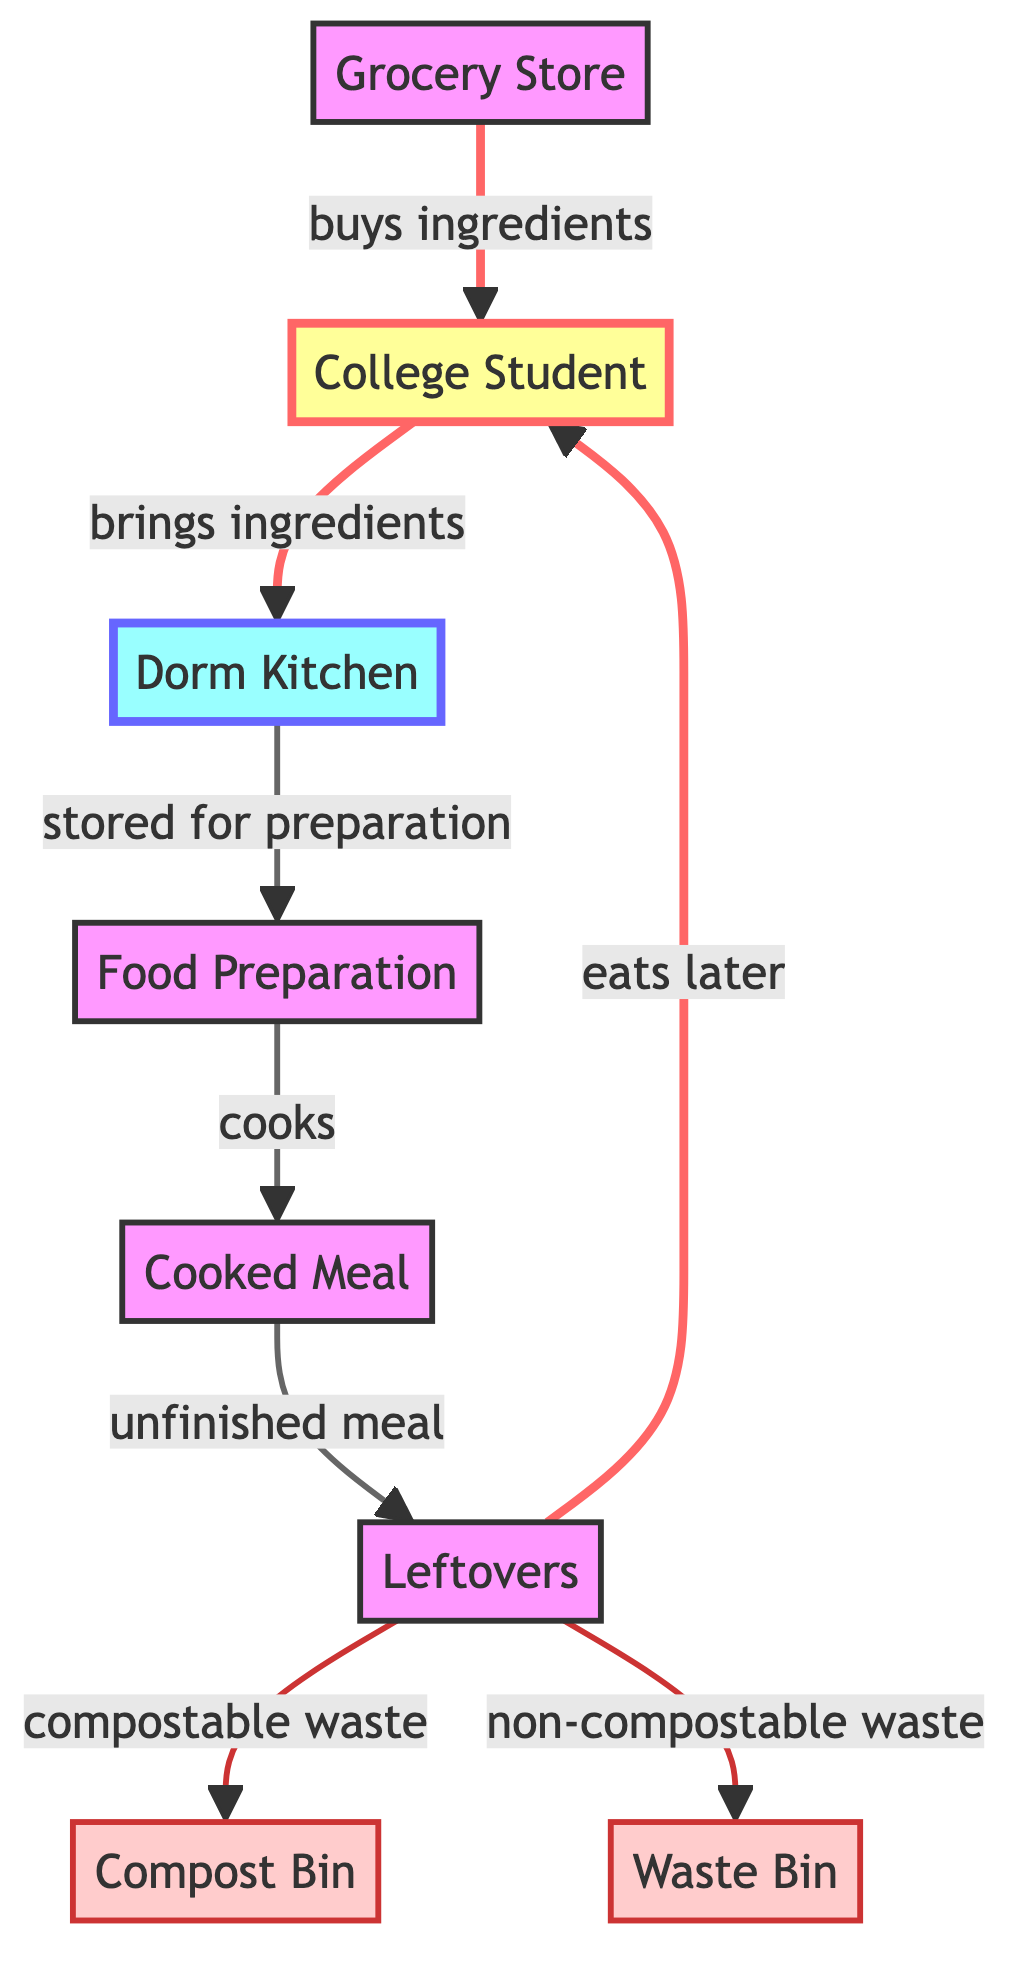What's the starting point of the food chain? The flowchart begins at the "Grocery Store", which shows where the ingredients are bought before starting the food preparation process.
Answer: Grocery Store How many waste destinations are there for leftovers? The diagram indicates two waste destinations for leftovers: the compost bin and the waste bin.
Answer: 2 What comes after the cooked meal in the flow? After the cooked meal, the diagram shows that it leads to leftovers, indicating that unfinished meals are saved for later.
Answer: Leftovers What does the college student do with leftovers? The diagram specifies that leftovers can either be eaten later by the college student or disposed of as waste, showing two actions related to leftovers.
Answer: Eats later, compostable waste, non-compostable waste Which process follows the dorm kitchen? After the dorm kitchen in the flowchart, the process that follows is food preparation, which indicates the next step after storing the ingredients.
Answer: Food Preparation What type of waste is put into the compost bin? The diagram describes that leftovers that are compostable are directed to the compost bin, specifying a specific type of leftover waste.
Answer: Compostable waste In total, how many nodes are there in the diagram? The diagram features a total of eight nodes, including the grocery store, college student, dorm kitchen, food preparation, cooked meal, leftovers, compost bin, and waste bin.
Answer: 8 What is created during the preparation process? According to the diagram, the result of the preparation process is the cooked meal, highlighting the outcome of this phase.
Answer: Cooked Meal Where do ingredients go after being brought to the dorm kitchen? The ingredients go to food preparation after being brought to the dorm kitchen, as indicated in the flow of the diagram.
Answer: Food Preparation 